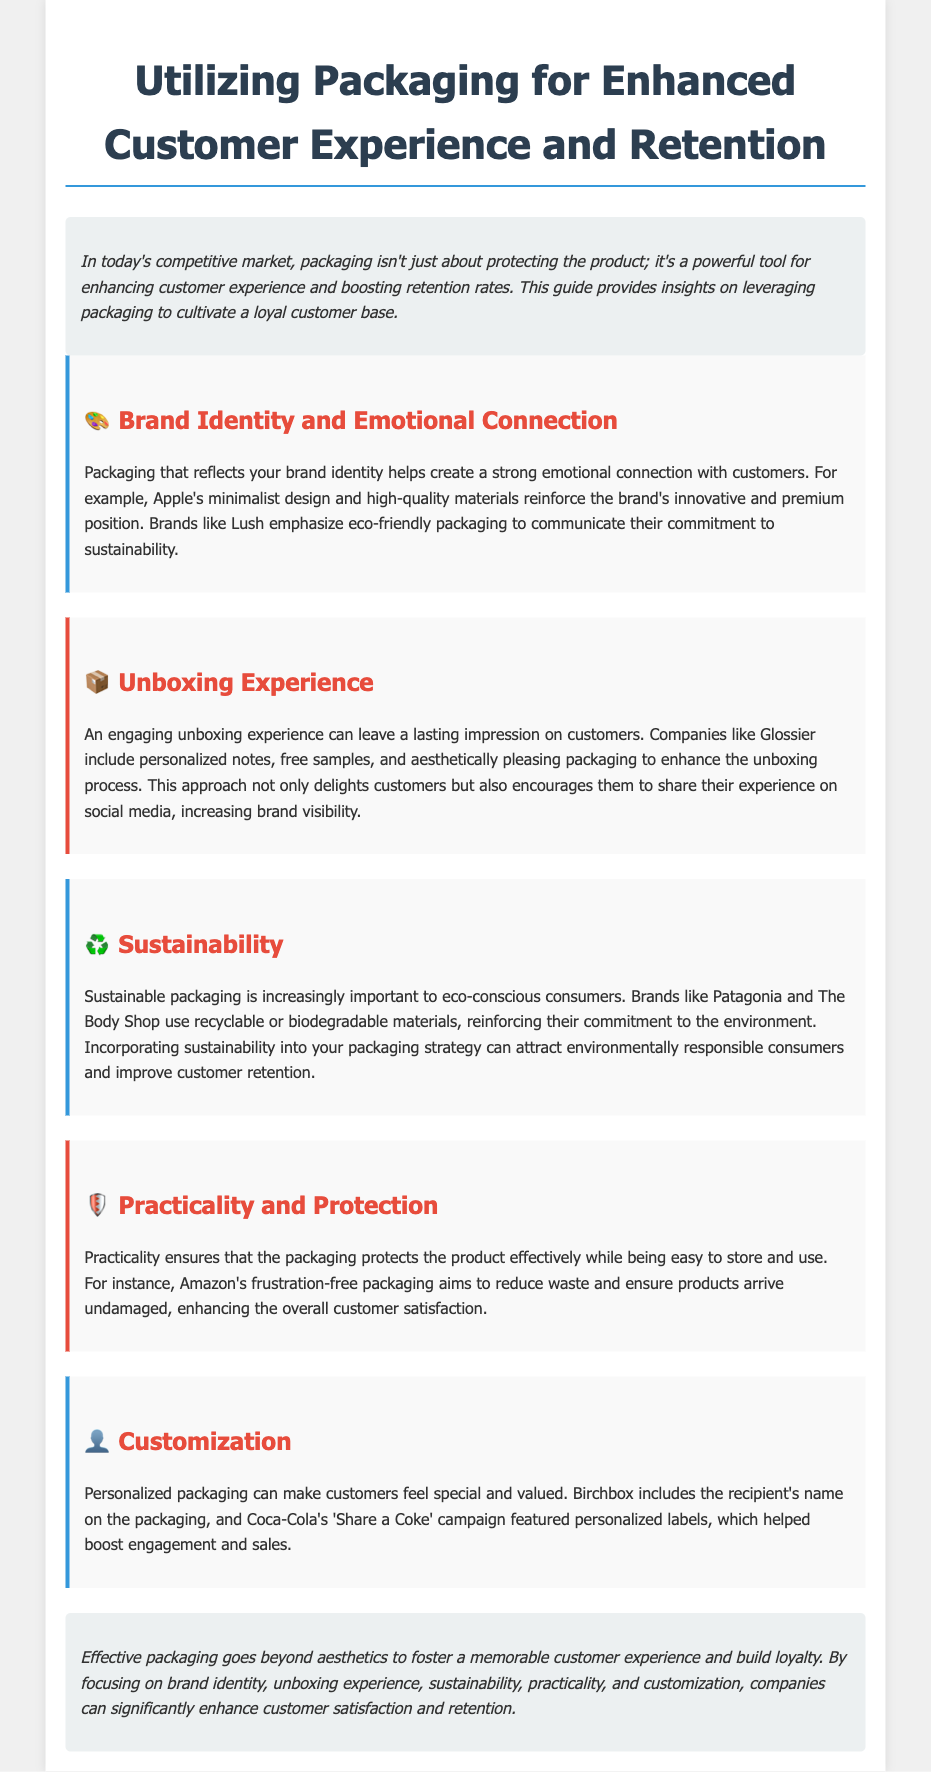What does packaging enhance? The document states that packaging enhances customer experience and boosts retention rates.
Answer: Customer experience and retention Which brand is known for minimalist design? The document mentions that Apple's packaging reflects its innovative and premium position through minimalist design.
Answer: Apple What type of packaging is emphasized by Lush? The document indicates that Lush emphasizes eco-friendly packaging to communicate its sustainability commitment.
Answer: Eco-friendly What experience can leave a lasting impression on customers? The document highlights that an engaging unboxing experience can leave a lasting impression.
Answer: Unboxing experience What material strategy do brands like Patagonia use? The document notes that brands like Patagonia use recyclable or biodegradable materials for sustainability.
Answer: Recyclable or biodegradable materials What does Amazon focus on in its packaging? The document specifies that Amazon's packaging aims to reduce waste and ensure products arrive undamaged.
Answer: Frustration-free What personalization technique is used by Birchbox? The document states that Birchbox includes the recipient's name on the packaging for personalization.
Answer: Recipient's name Which campaign featured personalized labels? The document refers to Coca-Cola's 'Share a Coke' campaign that featured personalized labels.
Answer: Share a Coke What is a key conclusion about effective packaging? The document concludes that effective packaging fosters a memorable customer experience and builds loyalty.
Answer: Fosters a memorable experience and builds loyalty 